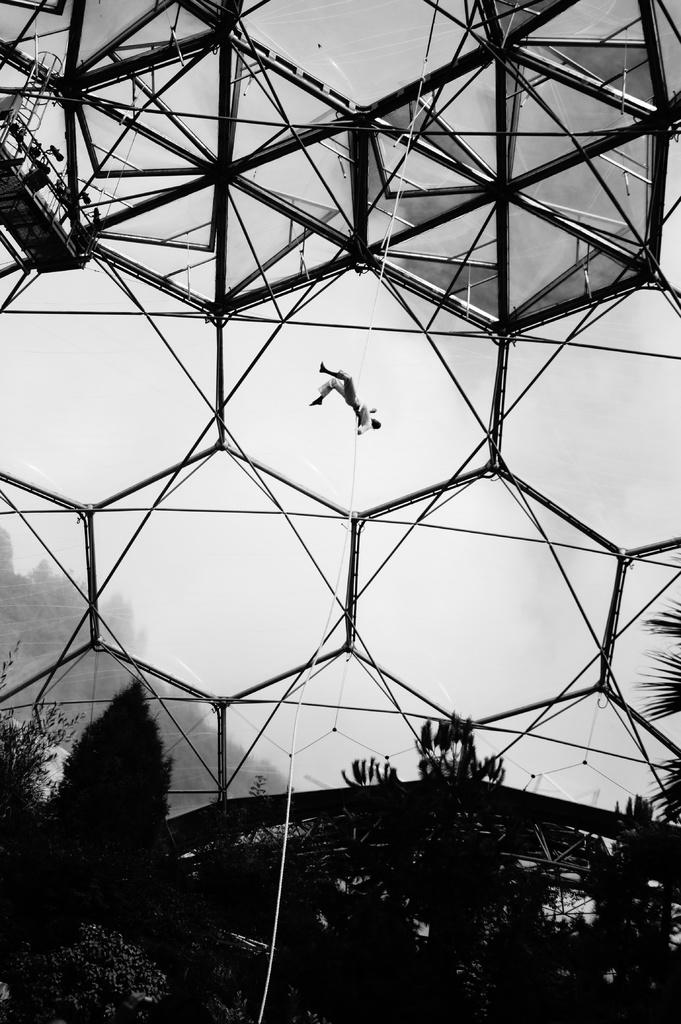What is the person in the image doing? The person is in the air with the help of a rope. What can be seen in the background of the image? There are trees visible in the image. What else can be seen in the image besides the person and trees? There are grills visible in the image. How many feet does the beetle have in the image? There is no beetle present in the image, so it is not possible to determine the number of feet it might have. 